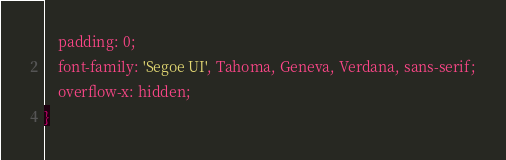Convert code to text. <code><loc_0><loc_0><loc_500><loc_500><_CSS_>    padding: 0;
    font-family: 'Segoe UI', Tahoma, Geneva, Verdana, sans-serif;
    overflow-x: hidden;
}</code> 